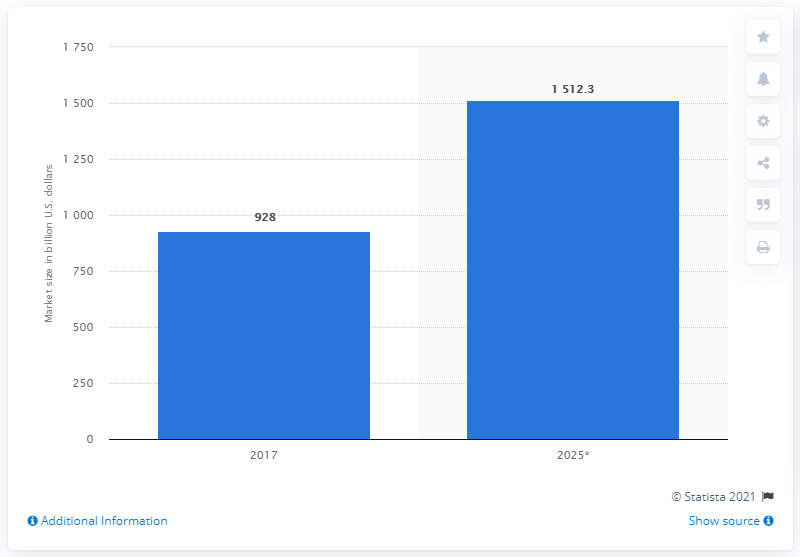Identify some key points in this picture. The global renewable energy market is expected to reach a value of $151.23 billion by the end of 2027. 